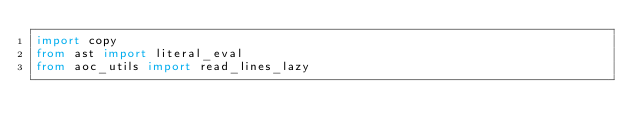<code> <loc_0><loc_0><loc_500><loc_500><_Python_>import copy
from ast import literal_eval
from aoc_utils import read_lines_lazy
</code> 